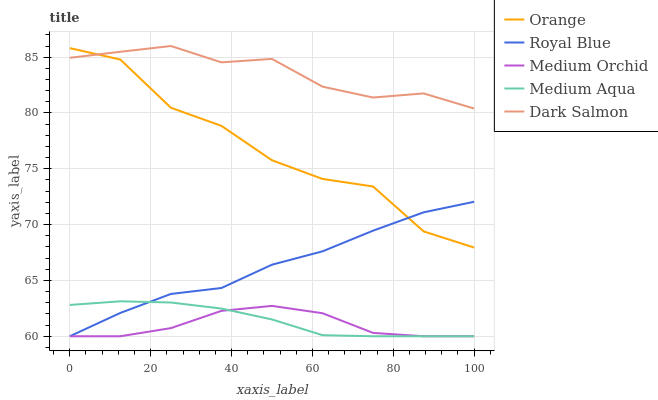Does Medium Orchid have the minimum area under the curve?
Answer yes or no. Yes. Does Dark Salmon have the maximum area under the curve?
Answer yes or no. Yes. Does Royal Blue have the minimum area under the curve?
Answer yes or no. No. Does Royal Blue have the maximum area under the curve?
Answer yes or no. No. Is Medium Aqua the smoothest?
Answer yes or no. Yes. Is Orange the roughest?
Answer yes or no. Yes. Is Royal Blue the smoothest?
Answer yes or no. No. Is Royal Blue the roughest?
Answer yes or no. No. Does Royal Blue have the lowest value?
Answer yes or no. Yes. Does Dark Salmon have the lowest value?
Answer yes or no. No. Does Dark Salmon have the highest value?
Answer yes or no. Yes. Does Royal Blue have the highest value?
Answer yes or no. No. Is Medium Orchid less than Orange?
Answer yes or no. Yes. Is Orange greater than Medium Aqua?
Answer yes or no. Yes. Does Dark Salmon intersect Orange?
Answer yes or no. Yes. Is Dark Salmon less than Orange?
Answer yes or no. No. Is Dark Salmon greater than Orange?
Answer yes or no. No. Does Medium Orchid intersect Orange?
Answer yes or no. No. 